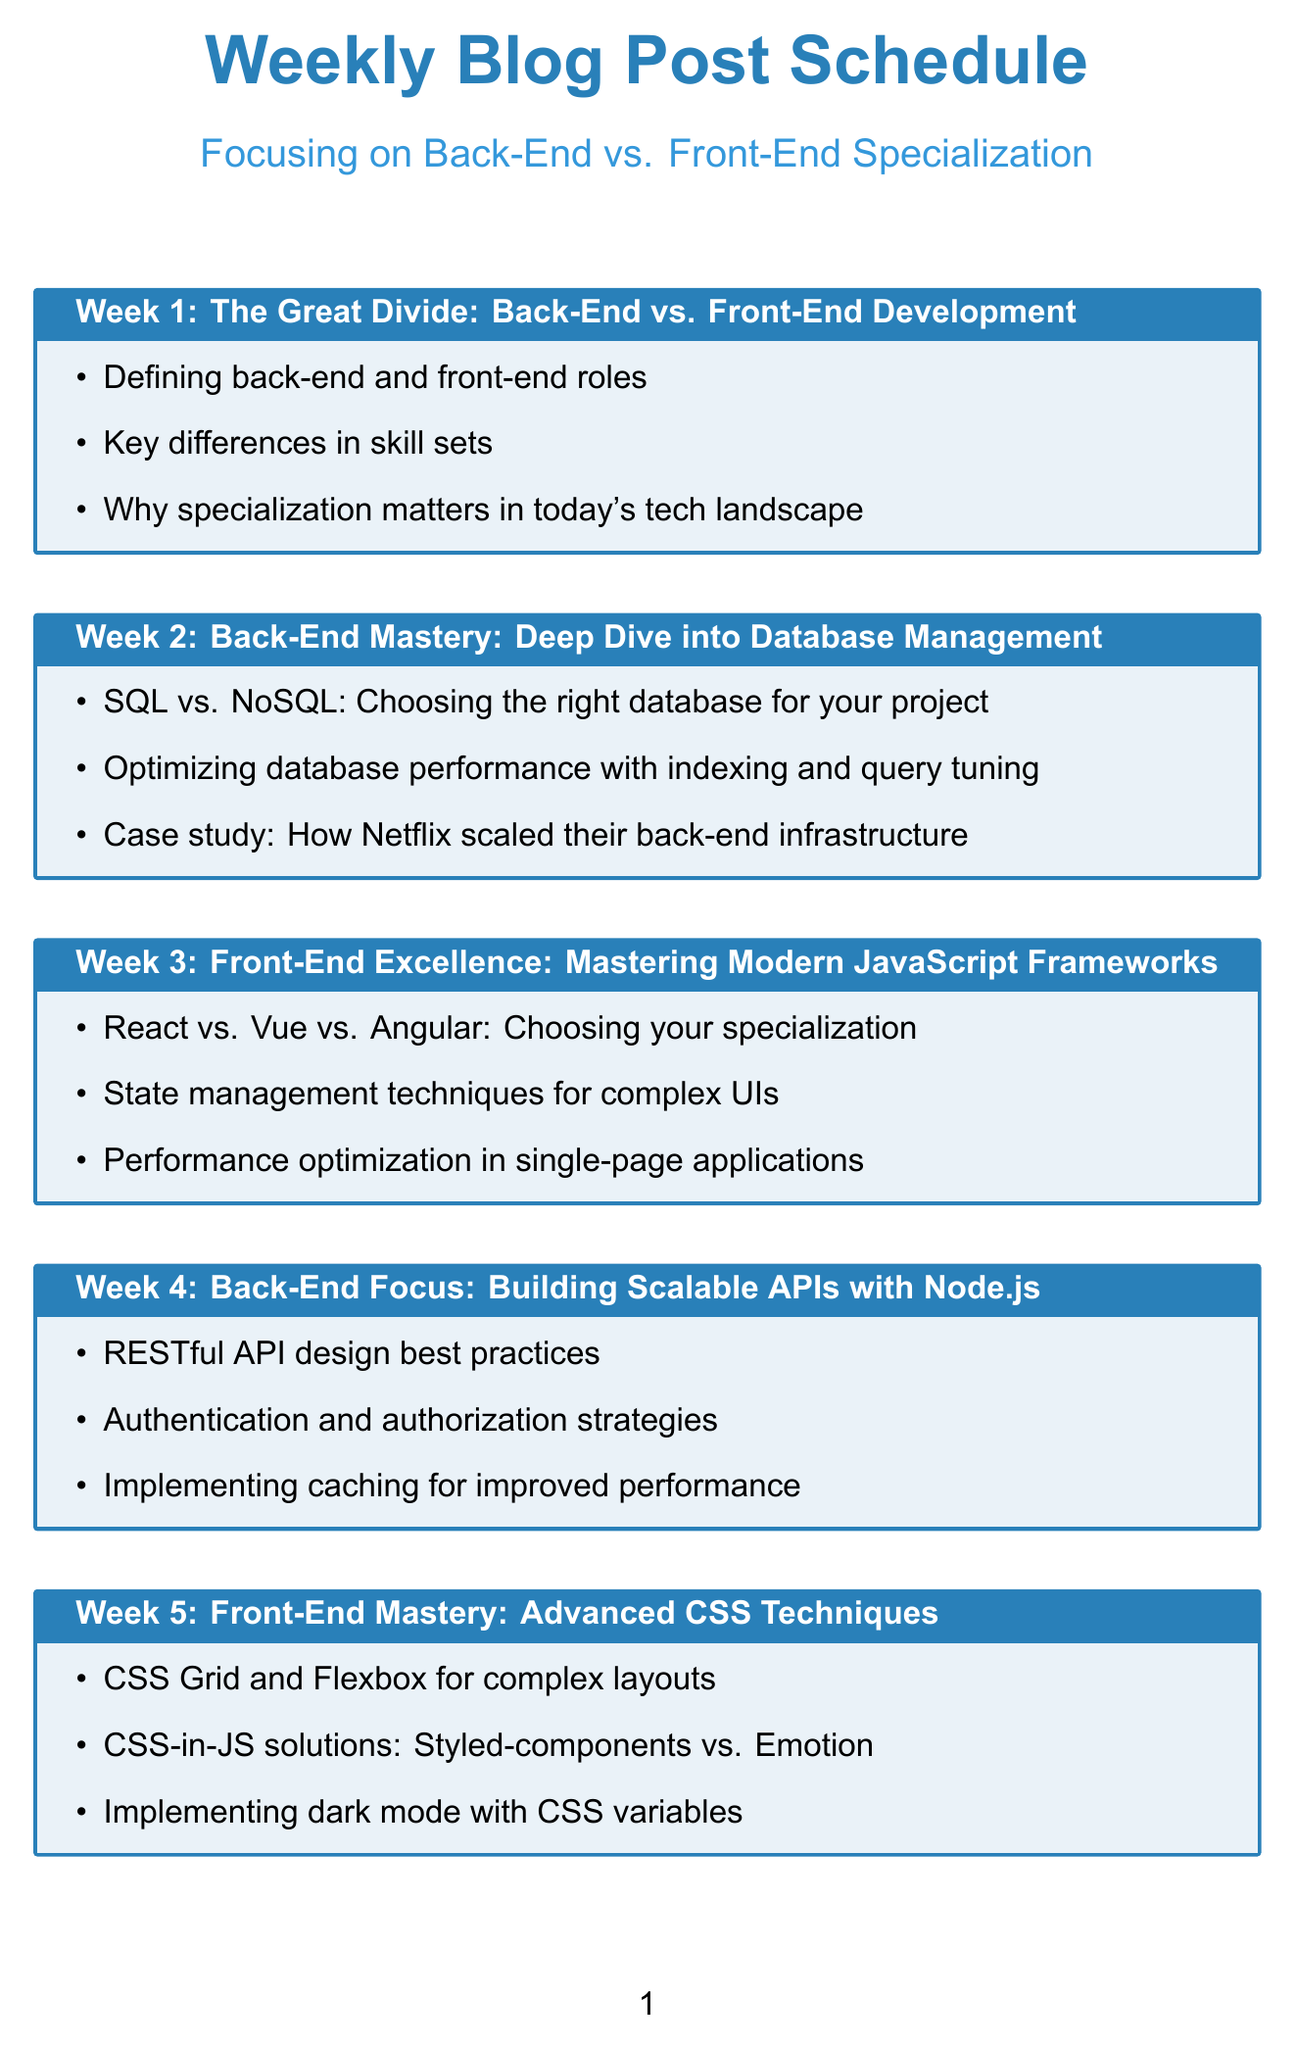what is the topic of week 1? The topic for week 1 is explicitly mentioned as the first entry in the document's table of contents, focusing on contrasting back-end and front-end development.
Answer: The Great Divide: Back-End vs. Front-End Development how many weeks are covered in this schedule? The document includes entries for twelve weeks, which is noted in the sequential numbering of the topics.
Answer: 12 what is the subtopic for week 3? The specific subtopics are listed beneath each week's main topic heading, providing insight into the focuses of that week.
Answer: React vs. Vue vs. Angular: Choosing your specialization which week focuses on microservices architecture? The document outlines week six as explicitly covering microservices, detailing its advantages and other related aspects.
Answer: Week 6 what is the main focus of week 9's topic? The primary focus of week 9 centers around optimizing load times and enhancing user experience, as denoted in the title.
Answer: Front-End Performance: Optimizing Load Times and User Experience what is the career topic discussed in week 12? Week 12 is dedicated to discussing career paths and industry trends, indicated prominently in the list of topics.
Answer: The Power of Specialization: Career Paths and Industry Trends which programming language is highlighted in week 4? The programming language featured in week 4 is Node.js, discussed as part of building scalable APIs.
Answer: Node.js how many subtopics are listed for back-end security in week 8? The document outlines three subtopics for week 8, detailing specific security measures relevant to back-end systems.
Answer: 3 what is the focus of week 7 regarding design? Week 7 focuses on accessibility and inclusive design, emphasizing the importance of web accessibility practices.
Answer: Accessibility and Inclusive Design 